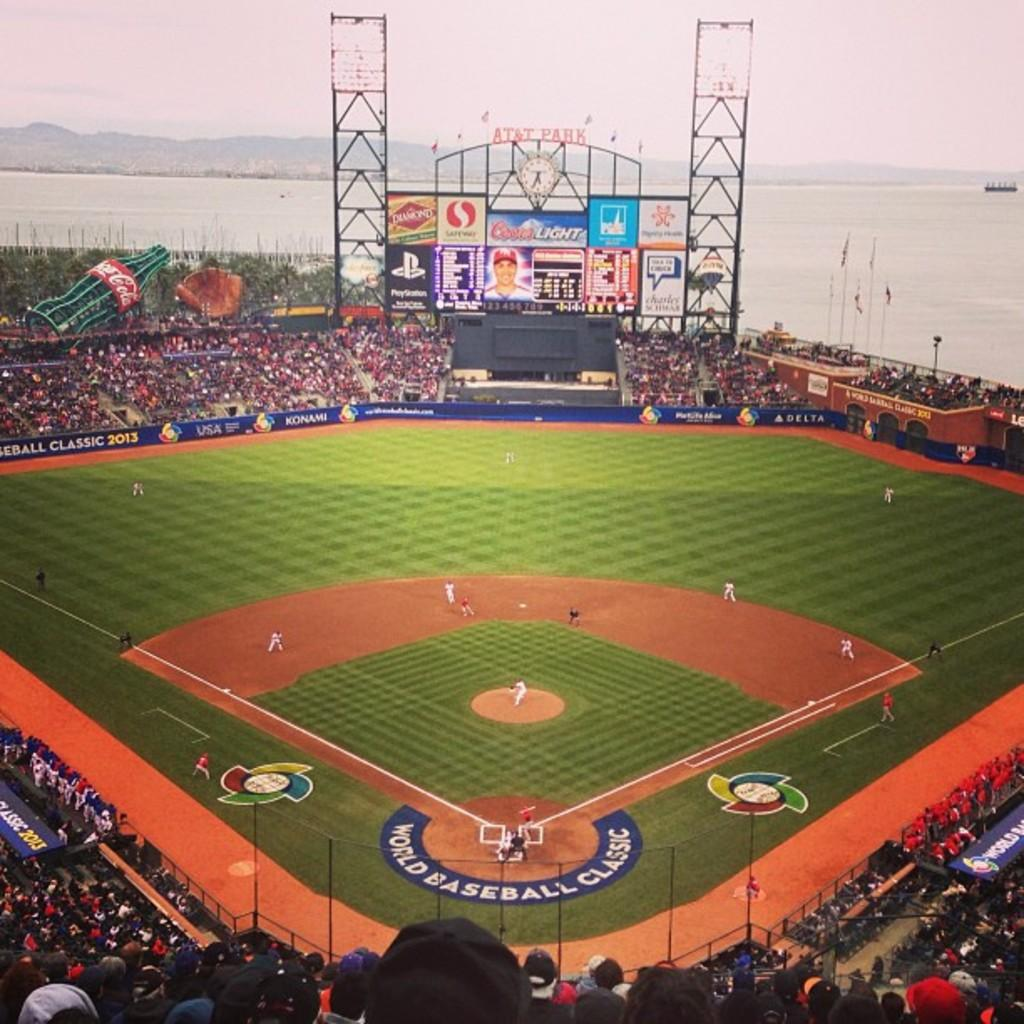<image>
Describe the image concisely. A baseball game being played at AT&T Park. 